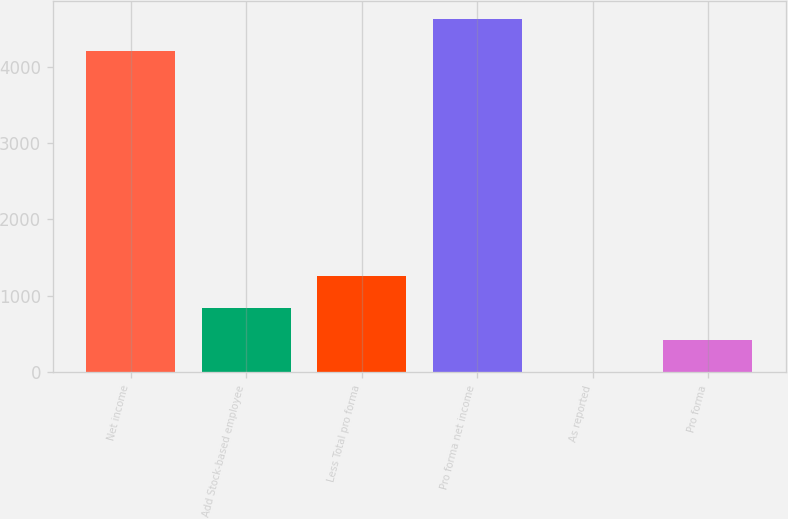<chart> <loc_0><loc_0><loc_500><loc_500><bar_chart><fcel>Net income<fcel>Add Stock-based employee<fcel>Less Total pro forma<fcel>Pro forma net income<fcel>As reported<fcel>Pro forma<nl><fcel>4202<fcel>843.49<fcel>1263.3<fcel>4621.81<fcel>3.87<fcel>423.68<nl></chart> 